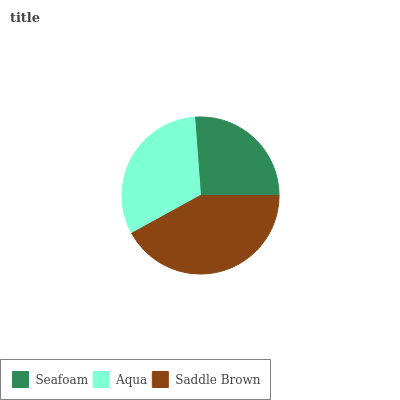Is Seafoam the minimum?
Answer yes or no. Yes. Is Saddle Brown the maximum?
Answer yes or no. Yes. Is Aqua the minimum?
Answer yes or no. No. Is Aqua the maximum?
Answer yes or no. No. Is Aqua greater than Seafoam?
Answer yes or no. Yes. Is Seafoam less than Aqua?
Answer yes or no. Yes. Is Seafoam greater than Aqua?
Answer yes or no. No. Is Aqua less than Seafoam?
Answer yes or no. No. Is Aqua the high median?
Answer yes or no. Yes. Is Aqua the low median?
Answer yes or no. Yes. Is Seafoam the high median?
Answer yes or no. No. Is Saddle Brown the low median?
Answer yes or no. No. 